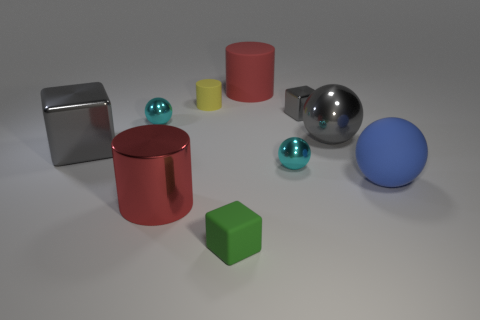There is a cube that is on the left side of the large red thing to the left of the red cylinder behind the red shiny object; what color is it?
Offer a very short reply. Gray. How many other objects are the same shape as the tiny yellow object?
Your answer should be compact. 2. What size is the cyan ball left of the red cylinder behind the blue sphere?
Your answer should be compact. Small. Is the size of the yellow rubber cylinder the same as the green matte block?
Ensure brevity in your answer.  Yes. Is there a red cylinder behind the gray cube right of the gray thing to the left of the yellow matte cylinder?
Offer a terse response. Yes. The red matte thing is what size?
Provide a succinct answer. Large. What number of gray objects have the same size as the green matte thing?
Give a very brief answer. 1. There is another red object that is the same shape as the red metallic thing; what material is it?
Offer a terse response. Rubber. There is a metal object that is left of the yellow rubber cylinder and behind the big gray metallic cube; what shape is it?
Your answer should be very brief. Sphere. There is a large matte thing that is to the right of the small gray thing; what is its shape?
Offer a very short reply. Sphere. 